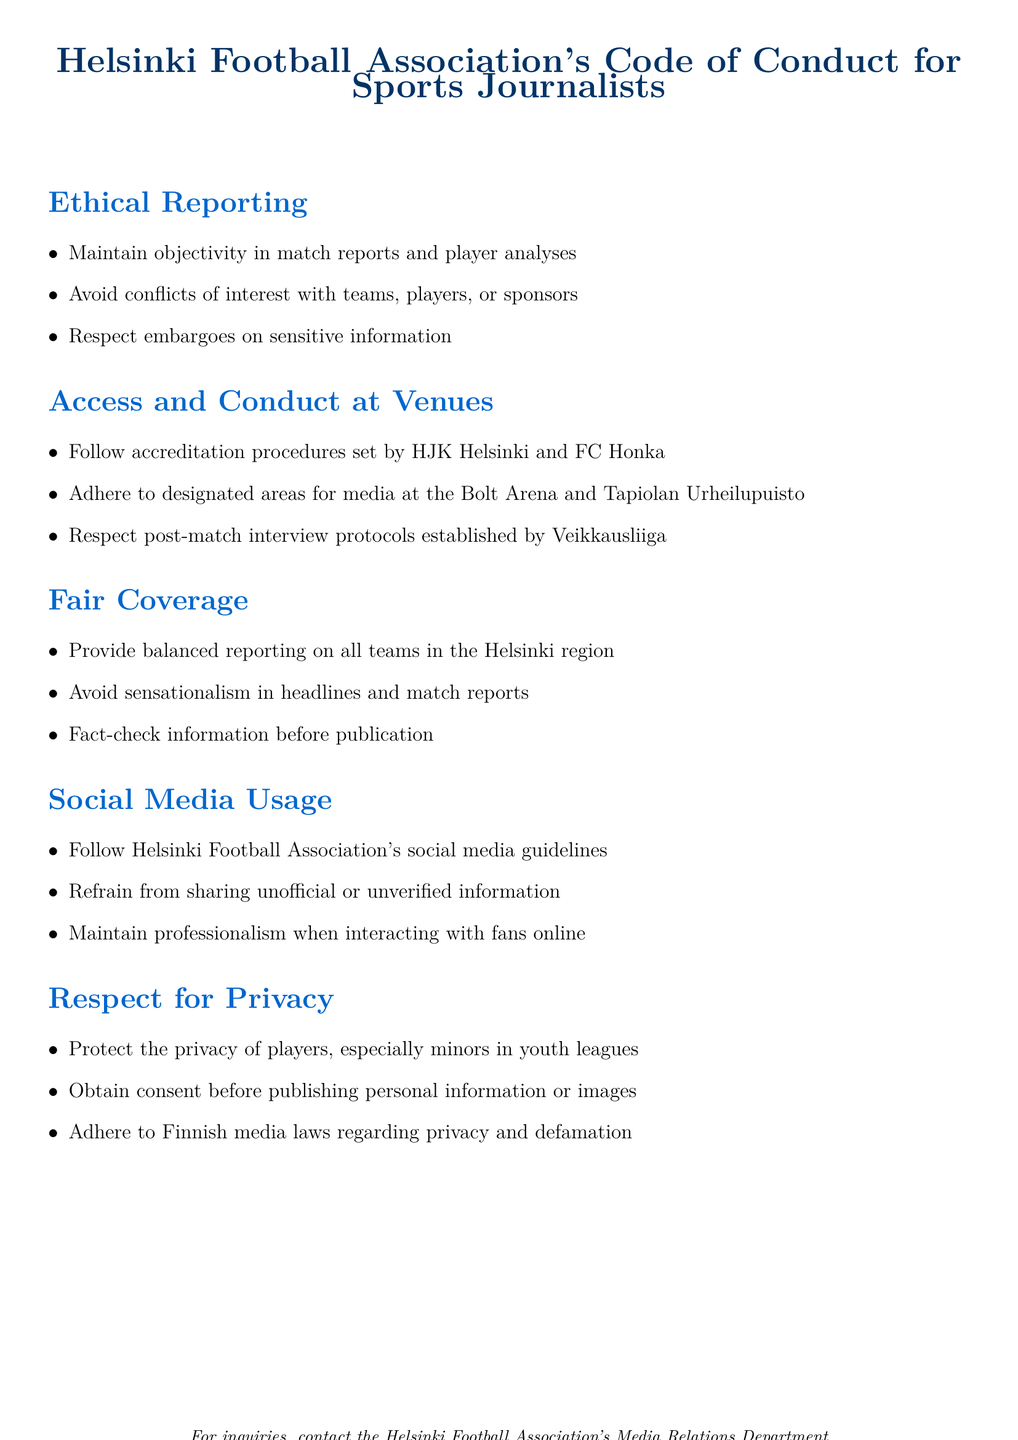What is the main title of the document? The title can be found at the top of the document and summarizes the document's purpose.
Answer: Helsinki Football Association's Code of Conduct for Sports Journalists What must sports journalists maintain in their reports? This is stated in the Ethical Reporting section and concerns the quality of reporting.
Answer: Objectivity Which teams are mentioned in the access and conduct section? This information specifies which teams' procedures journalists must follow.
Answer: HJK Helsinki and FC Honka What should be avoided according to the fair coverage principles? This relates to how information should be presented in match reports.
Answer: Sensationalism What is required to protect the privacy of players? This dictates the approach journalists must take concerning players' personal information.
Answer: Consent Where must journalists adhere to their designated areas? This specifies the venues where journalists must follow set rules.
Answer: Bolt Arena and Tapiolan Urheilupuisto What guidelines must be followed for social media usage? This refers to the guidelines set by the Helsinki Football Association regarding online conduct.
Answer: Helsinki Football Association's social media guidelines How often is the code of conduct reviewed? This pertains to how frequently the document is reassessed for relevance.
Answer: Annually 